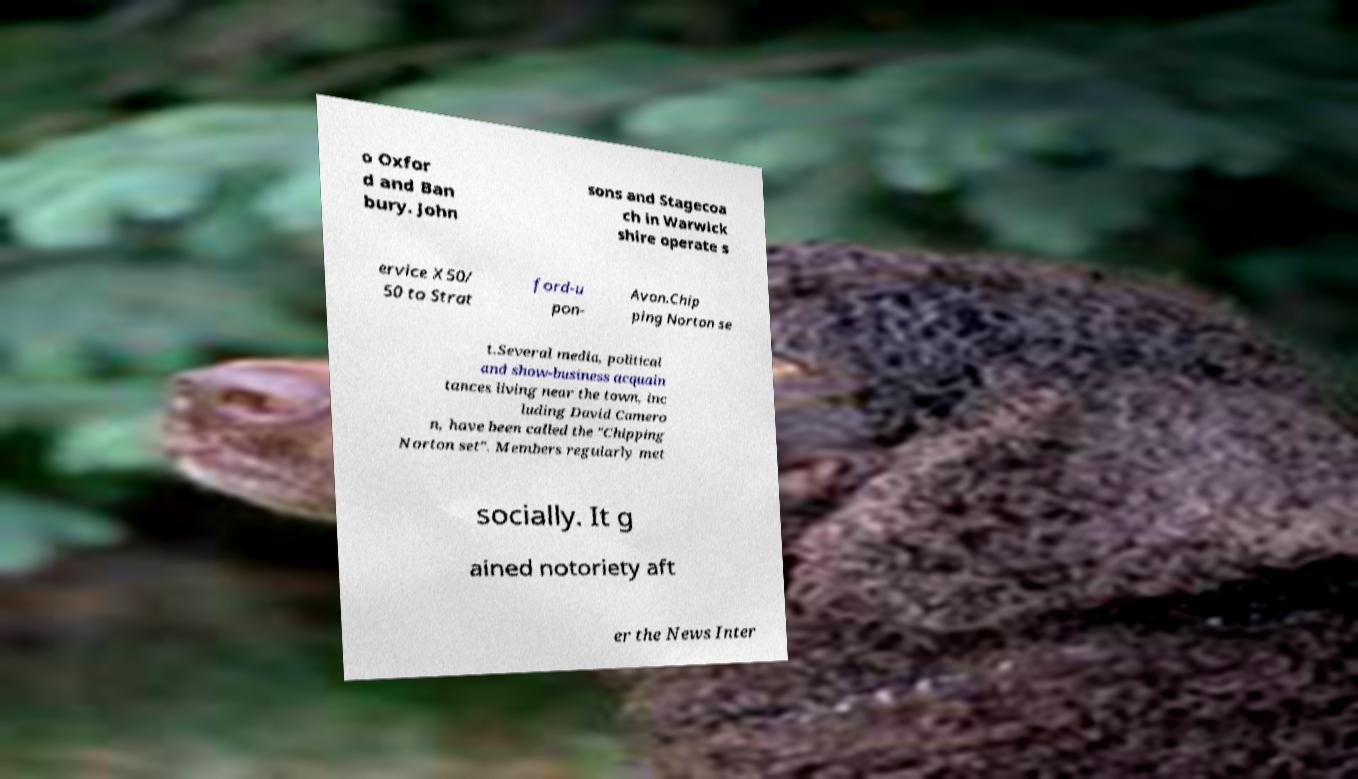Please identify and transcribe the text found in this image. o Oxfor d and Ban bury. John sons and Stagecoa ch in Warwick shire operate s ervice X50/ 50 to Strat ford-u pon- Avon.Chip ping Norton se t.Several media, political and show-business acquain tances living near the town, inc luding David Camero n, have been called the "Chipping Norton set". Members regularly met socially. It g ained notoriety aft er the News Inter 